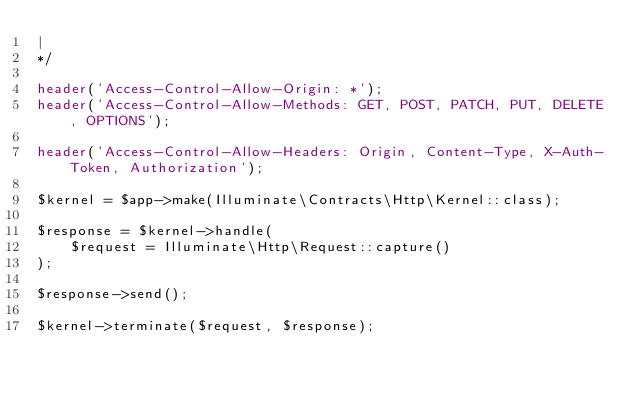Convert code to text. <code><loc_0><loc_0><loc_500><loc_500><_PHP_>|
*/

header('Access-Control-Allow-Origin: *');
header('Access-Control-Allow-Methods: GET, POST, PATCH, PUT, DELETE, OPTIONS');

header('Access-Control-Allow-Headers: Origin, Content-Type, X-Auth-Token, Authorization'); 

$kernel = $app->make(Illuminate\Contracts\Http\Kernel::class);

$response = $kernel->handle(
    $request = Illuminate\Http\Request::capture()
);

$response->send();

$kernel->terminate($request, $response);
</code> 